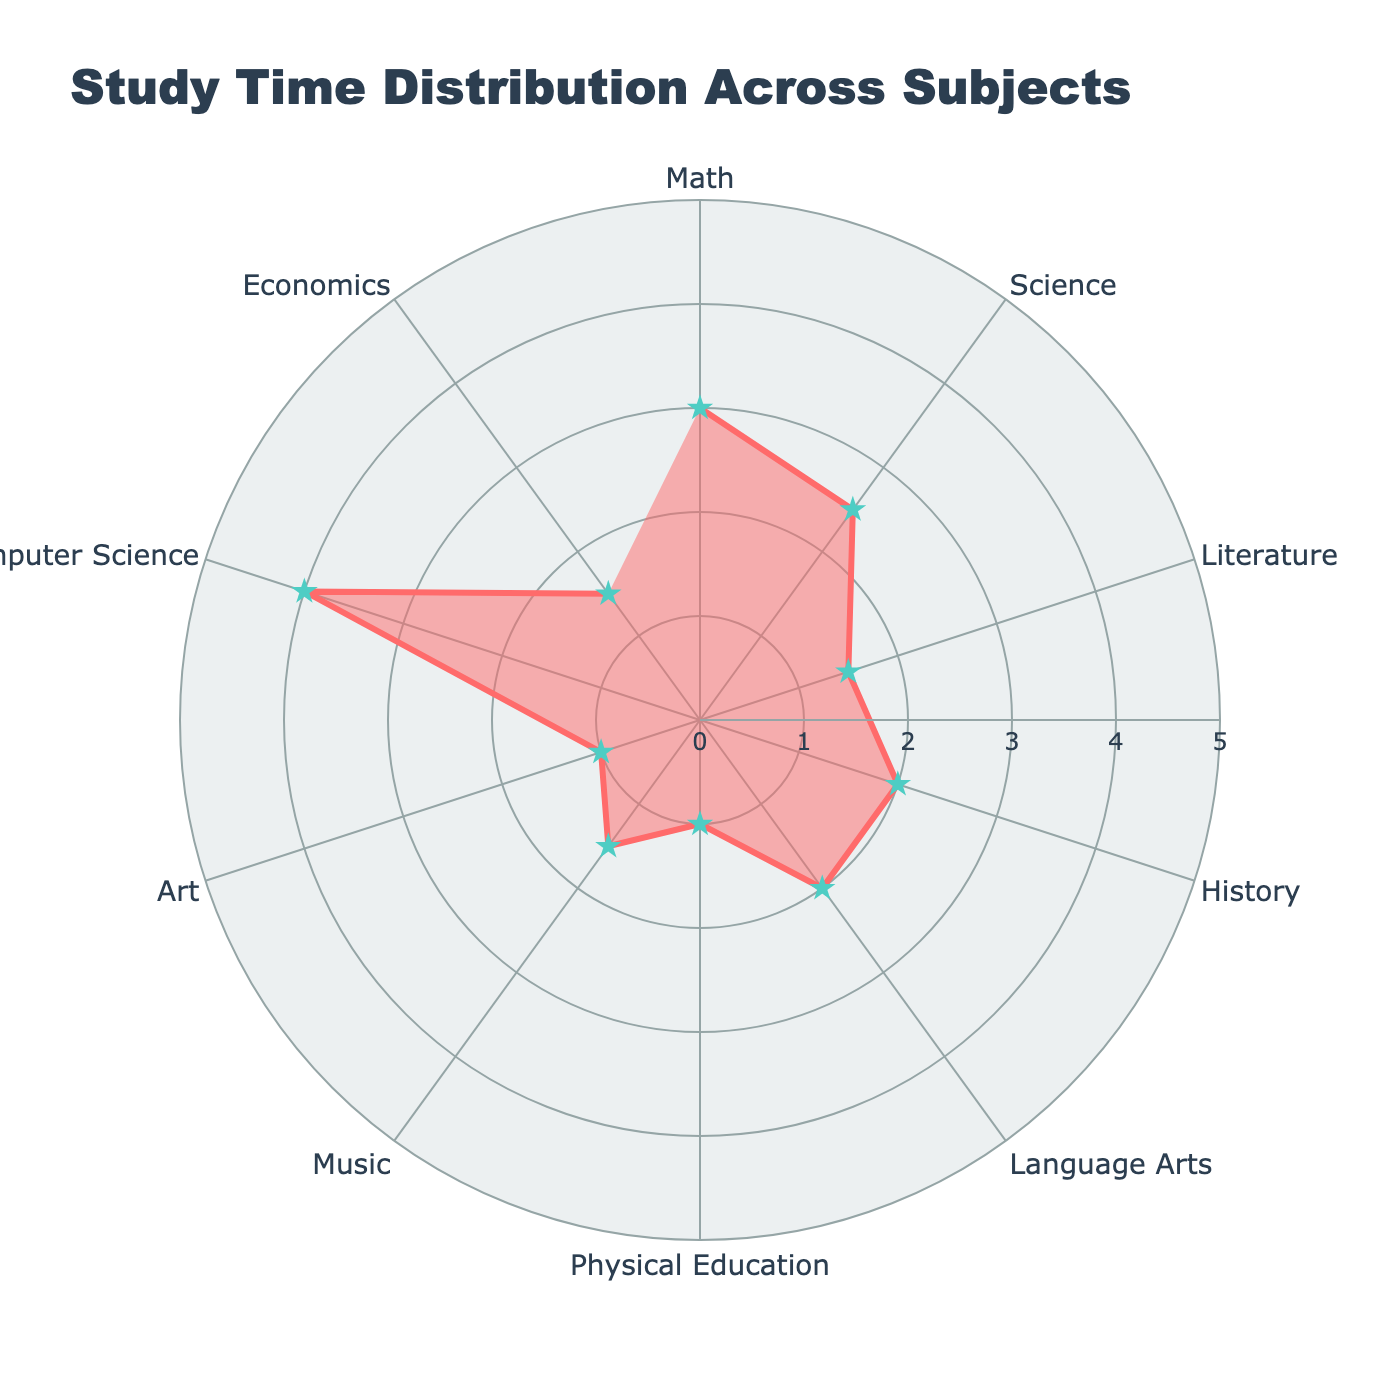what's the title of the chart? The title is written at the top of the chart in bigger letters. It describes the main focus of the chart to help viewers understand what they are looking at.
Answer: Study Time Distribution Across Subjects how many subjects are represented in the radar chart? To find the number of subjects, count the individual data points presented around the chart. Each data point represents a different subject.
Answer: 10 which subject has the highest average study time per week? Look at the length of the outer edges of the radar chart and identify the data point that goes furthest from the center. This represents the subject with the highest average study time.
Answer: Computer Science which subjects have the same average study time per week? By observing the points on the radar chart and matching their distances from the center, identify subjects that are plotted at the same radial distance.
Answer: Literature, Music, and Economics what is the average study time for Mathematics and Science combined? Locate the data points for Mathematics and Science on the radar chart, note their distances (3 hours for Math and 2.5 hours for Science), sum them and then divide by 2 to get the average study time.
Answer: 2.75 hours how does the study time for Physical Education compare with that for Literature? Locate and compare the positions of Physical Education and Literature on the radar chart. Note that Physical Education has 1 hour while Literature has 1.5 hours.
Answer: Less what is the total study time for all subjects per week? Find each study time value from the radar chart and sum them all: 3+2.5+1.5+2+2+1+1.5+1+4+1.5 = 20 hours.
Answer: 20 hours which subject has the least amount of study time per week? Check for the subject corresponding to the smallest radial distance from the center. This represents the subject with the least study time.
Answer: Art how much more study time is dedicated to Computer Science compared to Language Arts? Find the study time for both Computer Science (4 hours) and Language Arts (2 hours), then subtract the smaller value from the larger one: 4 - 2 = 2 hours.
Answer: 2 hours what is the median study time across all subjects? List out all the study times: [3, 2.5, 1.5, 2, 2, 1, 1.5, 1, 4, 1.5], sort them: [1, 1, 1, 1.5, 1.5, 1.5, 2, 2, 2.5, 3, 4], and find the middle value. With 10 points, the median is the average of the 5th and 6th values: (1.5+1.5)/2 = 1.5.
Answer: 1.5 hours 